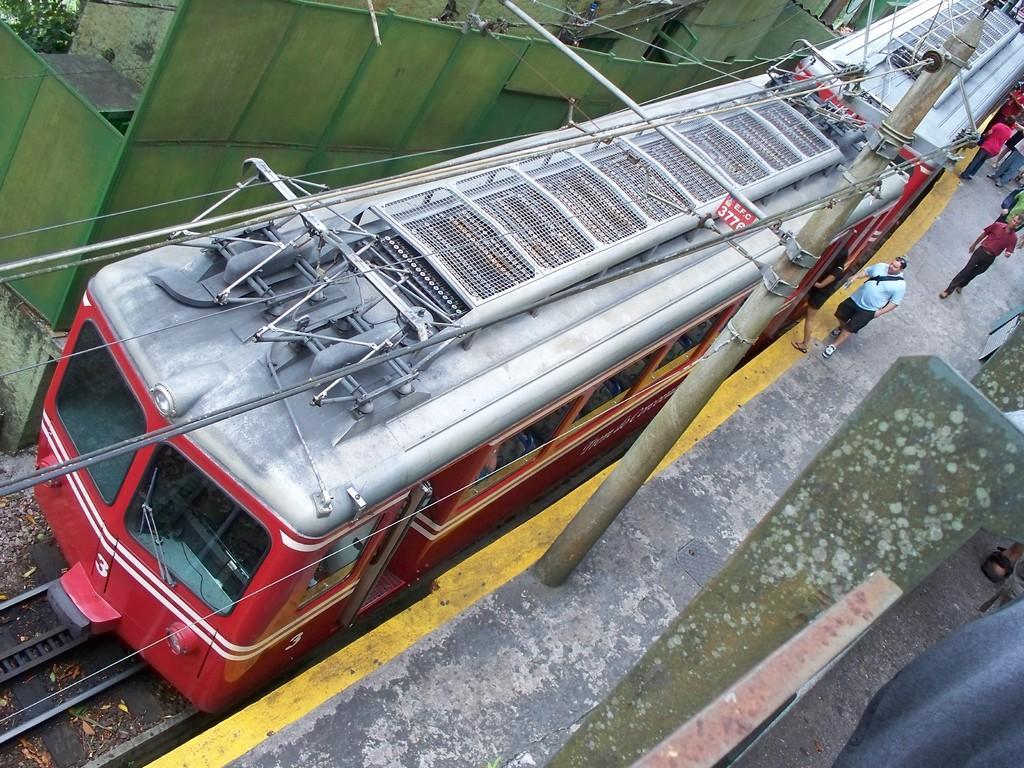In one or two sentences, can you explain what this image depicts? In this image I can see a train on the railway track. There are people on the platform , there are cables, there is a pole, a building and in the bottom right corner there is a metal object. 